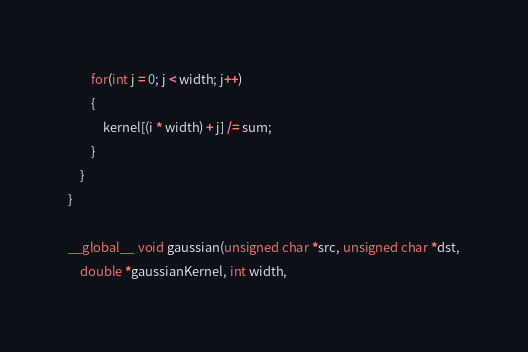Convert code to text. <code><loc_0><loc_0><loc_500><loc_500><_Cuda_>		for(int j = 0; j < width; j++)
		{
			kernel[(i * width) + j] /= sum;
		}
	}
}

__global__ void gaussian(unsigned char *src, unsigned char *dst,
	double *gaussianKernel, int width,</code> 